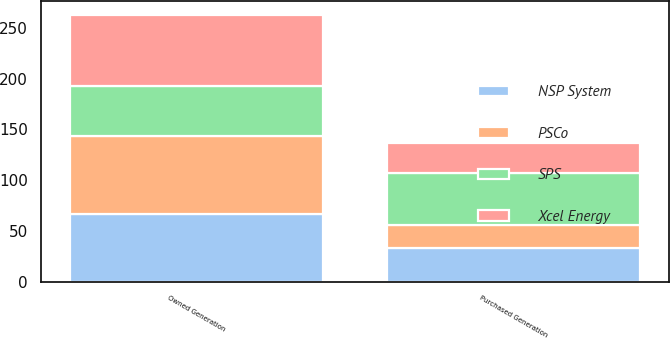Convert chart to OTSL. <chart><loc_0><loc_0><loc_500><loc_500><stacked_bar_chart><ecel><fcel>Owned Generation<fcel>Purchased Generation<nl><fcel>NSP System<fcel>67<fcel>33<nl><fcel>PSCo<fcel>77<fcel>23<nl><fcel>Xcel Energy<fcel>70<fcel>30<nl><fcel>SPS<fcel>49<fcel>51<nl></chart> 